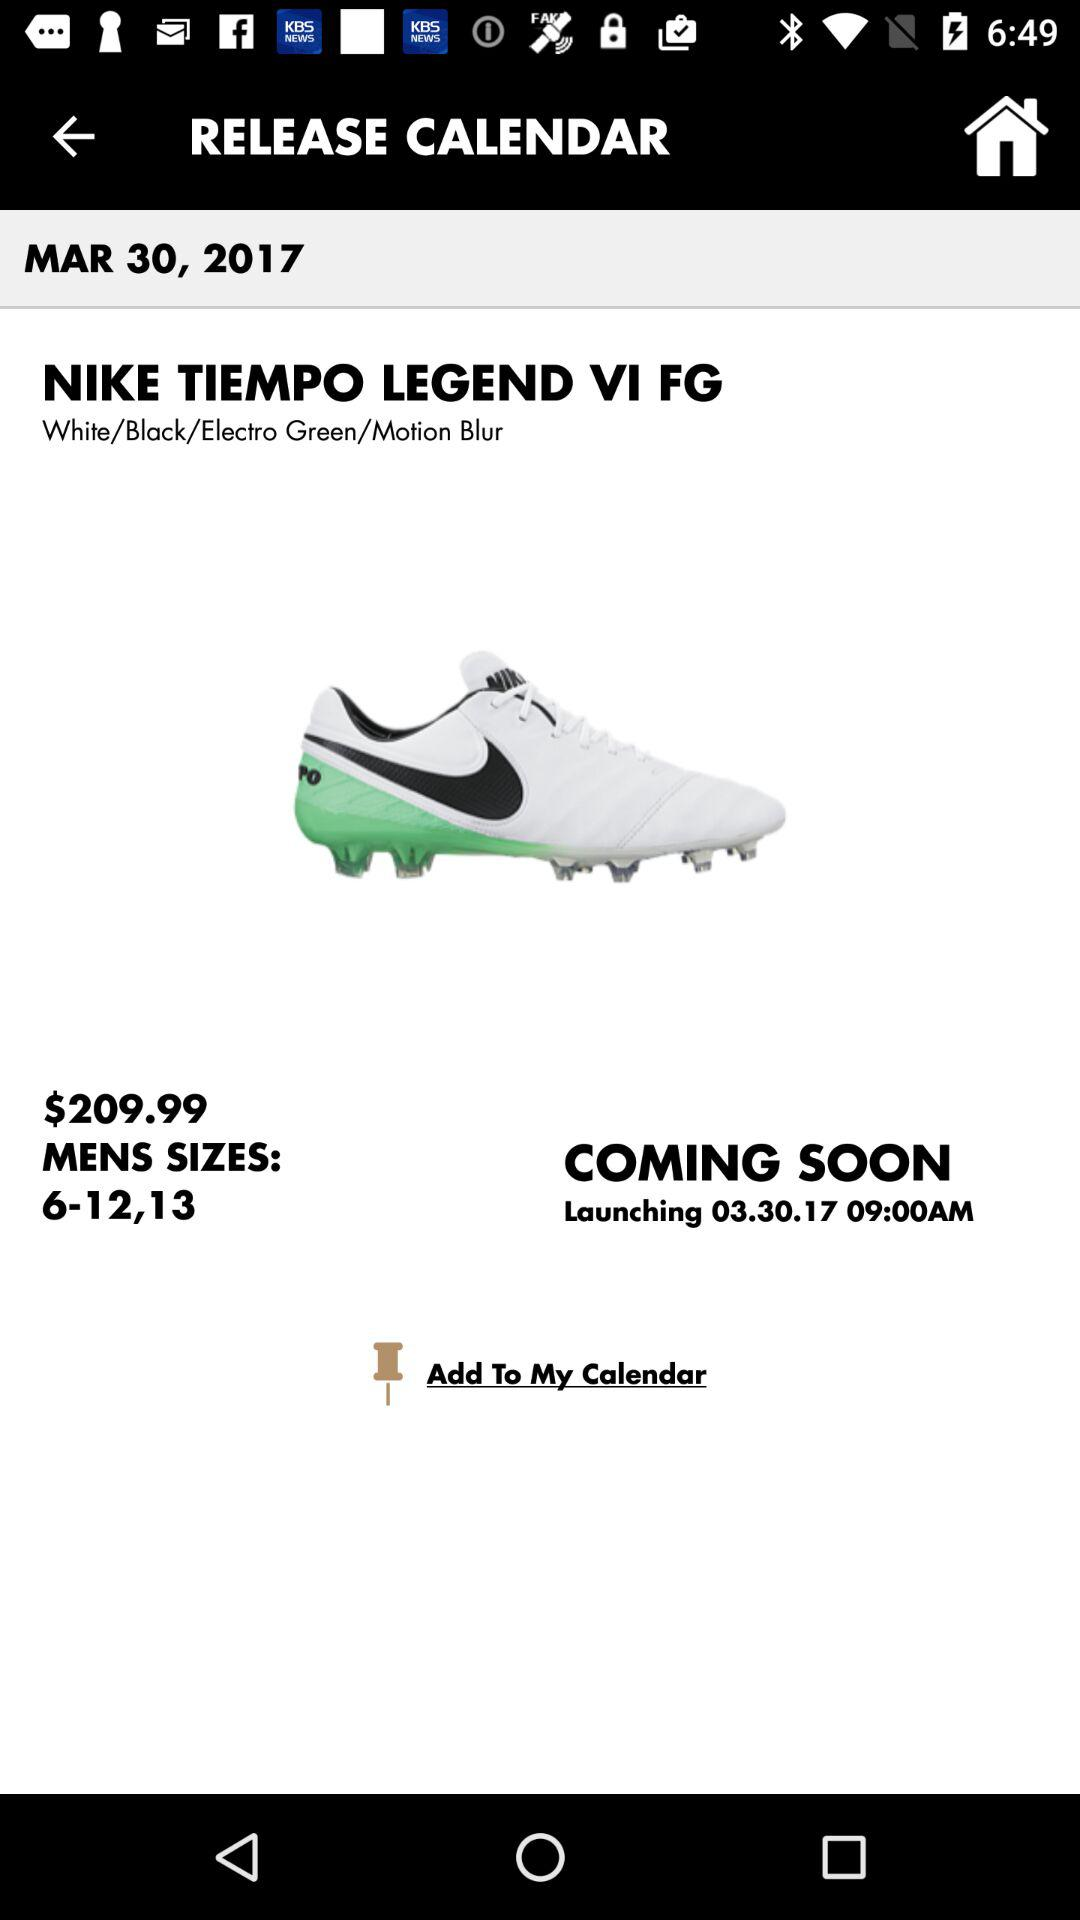What is the date on the screen? The date on the screen is March 30, 2017. 